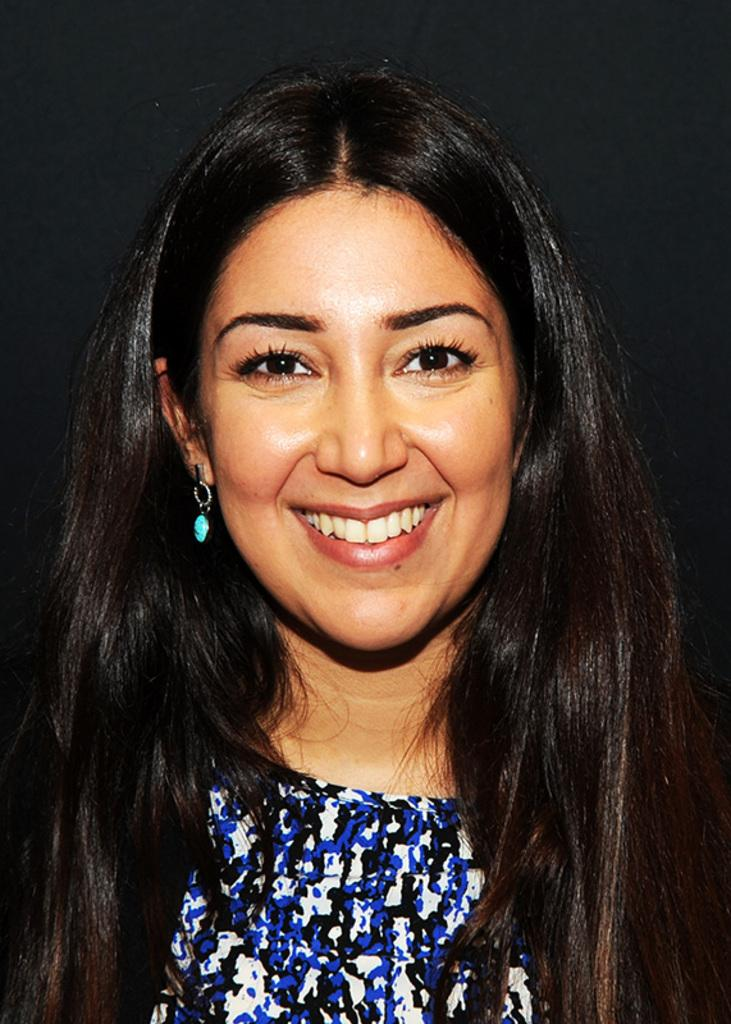Who is present in the image? There is a woman in the image. What is the woman doing in the image? The woman is smiling. What type of hen can be seen in the image? There is no hen present in the image; it only features a woman who is smiling. 